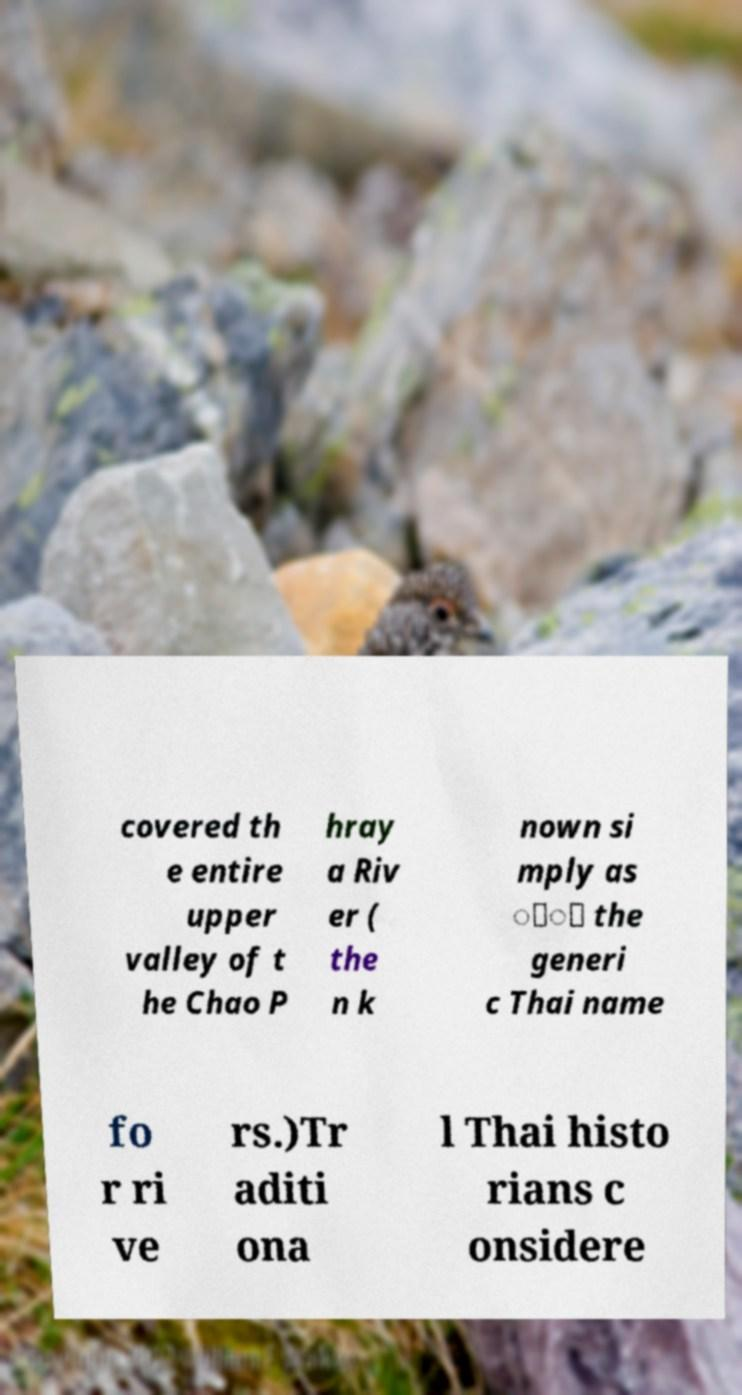For documentation purposes, I need the text within this image transcribed. Could you provide that? covered th e entire upper valley of t he Chao P hray a Riv er ( the n k nown si mply as ่้ the generi c Thai name fo r ri ve rs.)Tr aditi ona l Thai histo rians c onsidere 